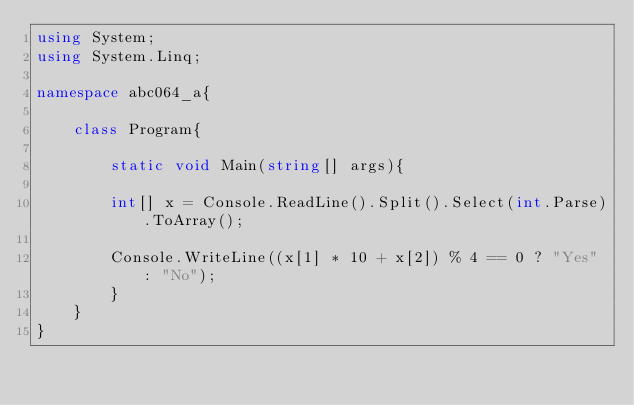Convert code to text. <code><loc_0><loc_0><loc_500><loc_500><_C#_>using System;
using System.Linq;

namespace abc064_a{
    
    class Program{
    
        static void Main(string[] args){
        
        int[] x = Console.ReadLine().Split().Select(int.Parse).ToArray();
        
        Console.WriteLine((x[1] * 10 + x[2]) % 4 == 0 ? "Yes" : "No");
        }
    }
}</code> 